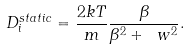<formula> <loc_0><loc_0><loc_500><loc_500>D ^ { s t a t i c } _ { i } = \frac { 2 k T } { m } \frac { \beta } { \beta ^ { 2 } + \ w ^ { 2 } } .</formula> 